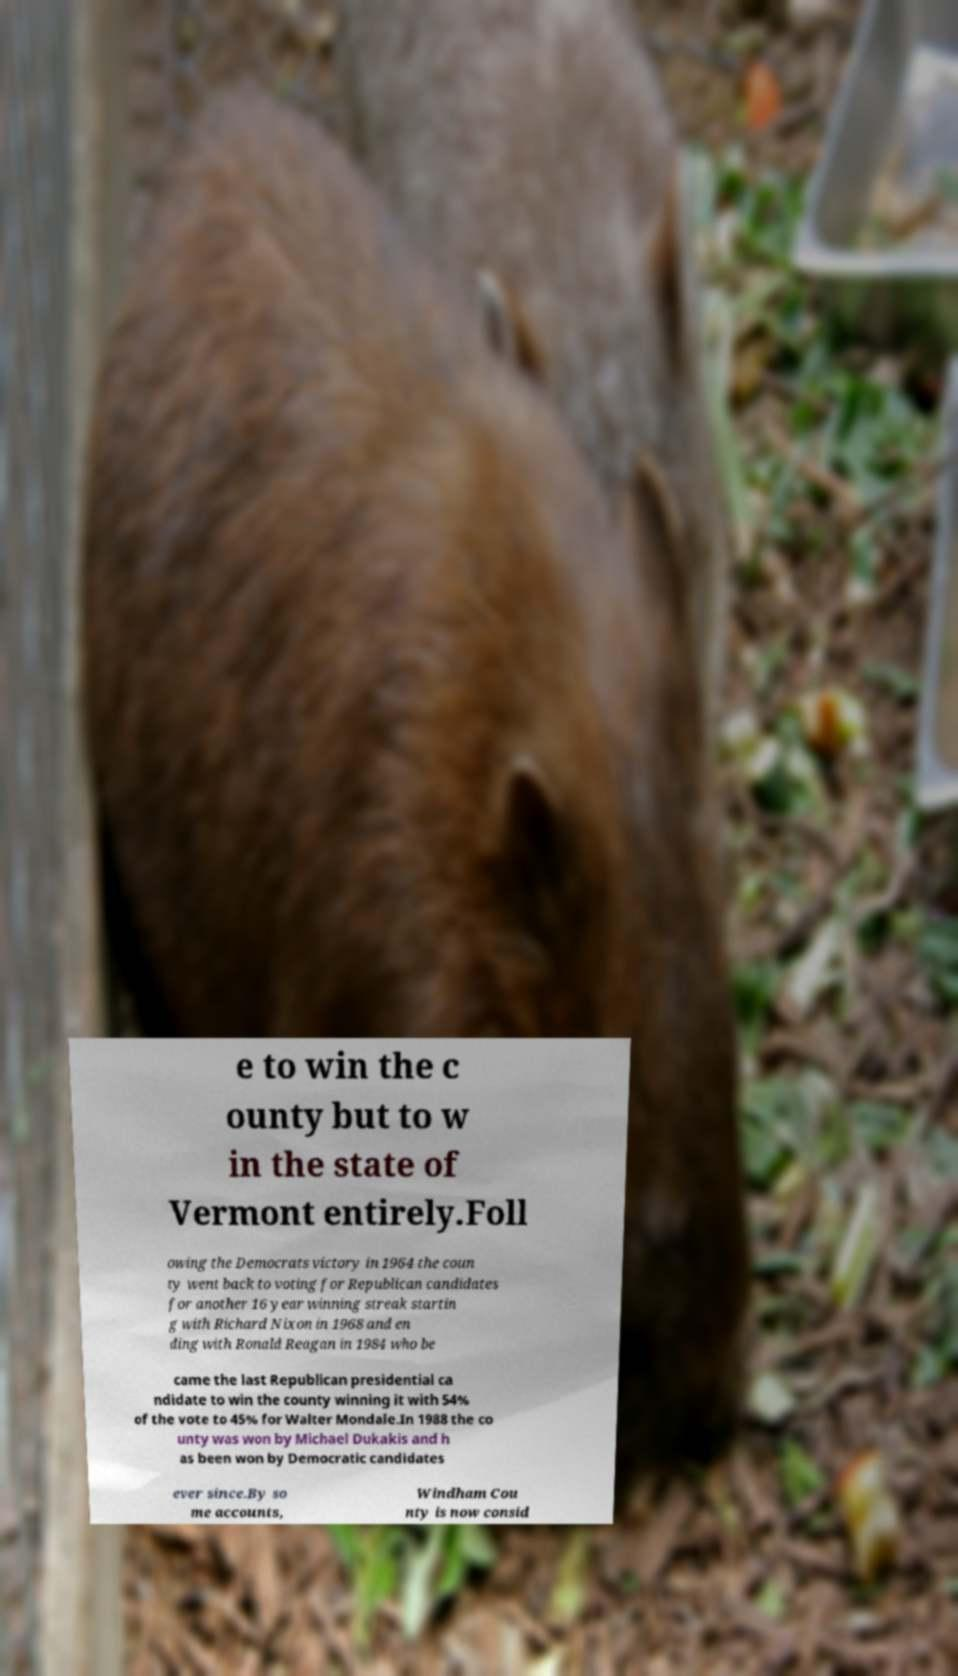Please read and relay the text visible in this image. What does it say? e to win the c ounty but to w in the state of Vermont entirely.Foll owing the Democrats victory in 1964 the coun ty went back to voting for Republican candidates for another 16 year winning streak startin g with Richard Nixon in 1968 and en ding with Ronald Reagan in 1984 who be came the last Republican presidential ca ndidate to win the county winning it with 54% of the vote to 45% for Walter Mondale.In 1988 the co unty was won by Michael Dukakis and h as been won by Democratic candidates ever since.By so me accounts, Windham Cou nty is now consid 